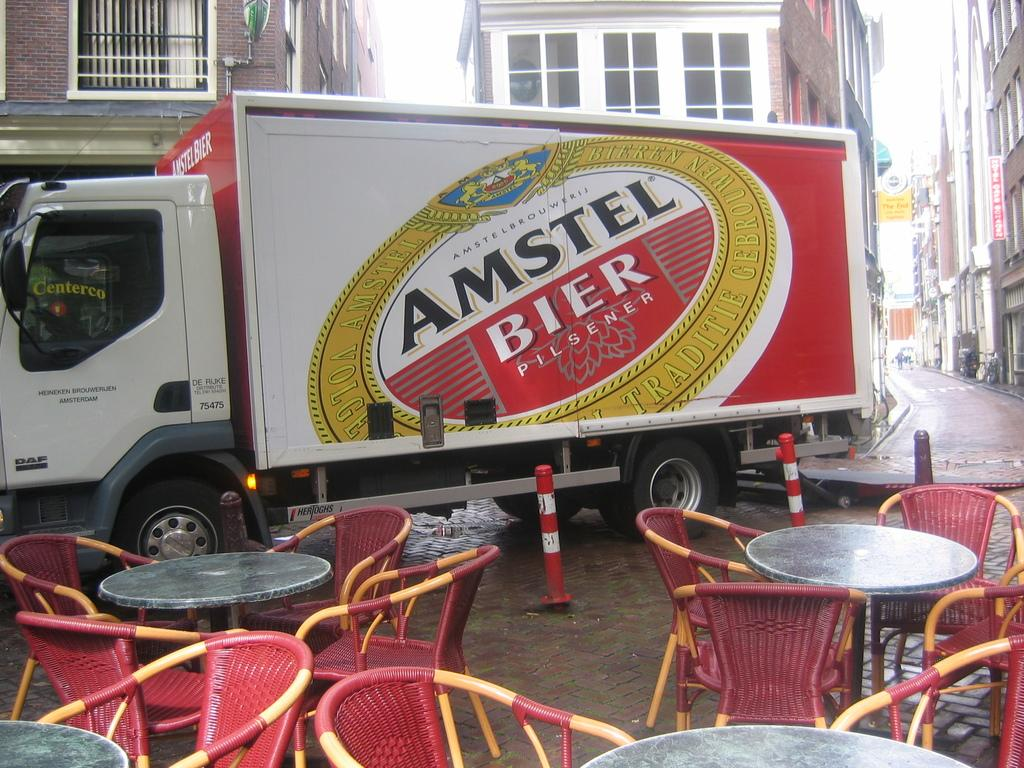What type of furniture is visible in the image? There are tables and chairs in the image. What else can be seen in the image besides furniture? There is a vehicle with a trailer in the image. What is on the trailer of the vehicle? There is a poster on the trailer of the vehicle. What is the setting of the image? There are buildings in the background of the image, and there is a road in the image. How many babies are running on the spot in the image? There are no babies present in the image, and no one is running on the spot. What type of spot is visible on the poster on the trailer? The provided facts do not mention any spots on the poster, only that there is a poster on the trailer. 